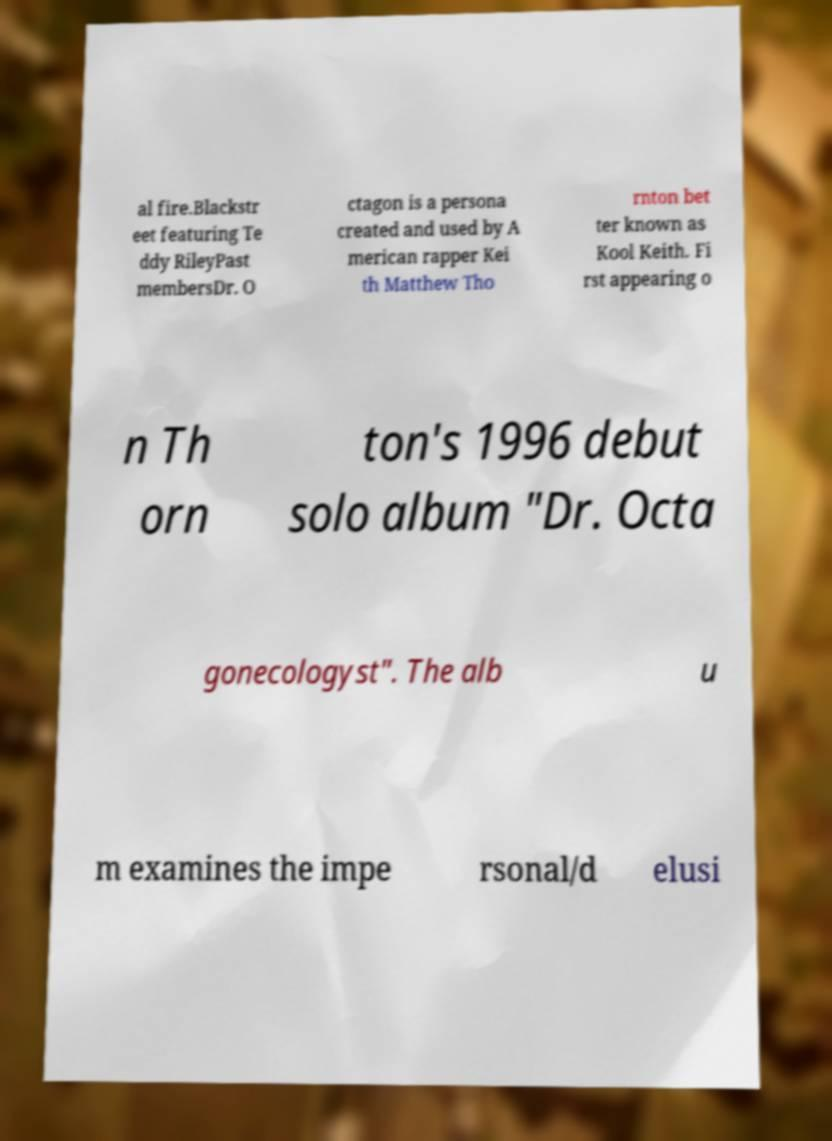Please read and relay the text visible in this image. What does it say? al fire.Blackstr eet featuring Te ddy RileyPast membersDr. O ctagon is a persona created and used by A merican rapper Kei th Matthew Tho rnton bet ter known as Kool Keith. Fi rst appearing o n Th orn ton's 1996 debut solo album "Dr. Octa gonecologyst". The alb u m examines the impe rsonal/d elusi 